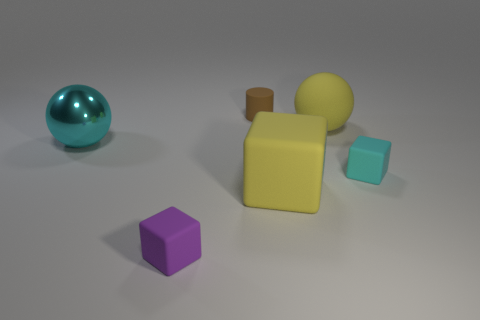Are there fewer big yellow things behind the large yellow ball than tiny cyan matte cubes that are behind the purple matte cube?
Give a very brief answer. Yes. How big is the metallic object to the left of the big block?
Your answer should be compact. Large. There is a matte thing that is the same color as the large metal thing; what size is it?
Your response must be concise. Small. Is there a small cube made of the same material as the tiny brown cylinder?
Provide a succinct answer. Yes. Is the big yellow ball made of the same material as the big cyan ball?
Your response must be concise. No. What is the color of the rubber cube that is the same size as the cyan rubber thing?
Give a very brief answer. Purple. What number of other things are the same shape as the big metallic thing?
Provide a short and direct response. 1. There is a cyan metal ball; does it have the same size as the matte thing that is on the left side of the small cylinder?
Your answer should be compact. No. How many objects are either green matte balls or big rubber objects?
Offer a terse response. 2. How many other things are there of the same size as the brown object?
Your answer should be compact. 2. 